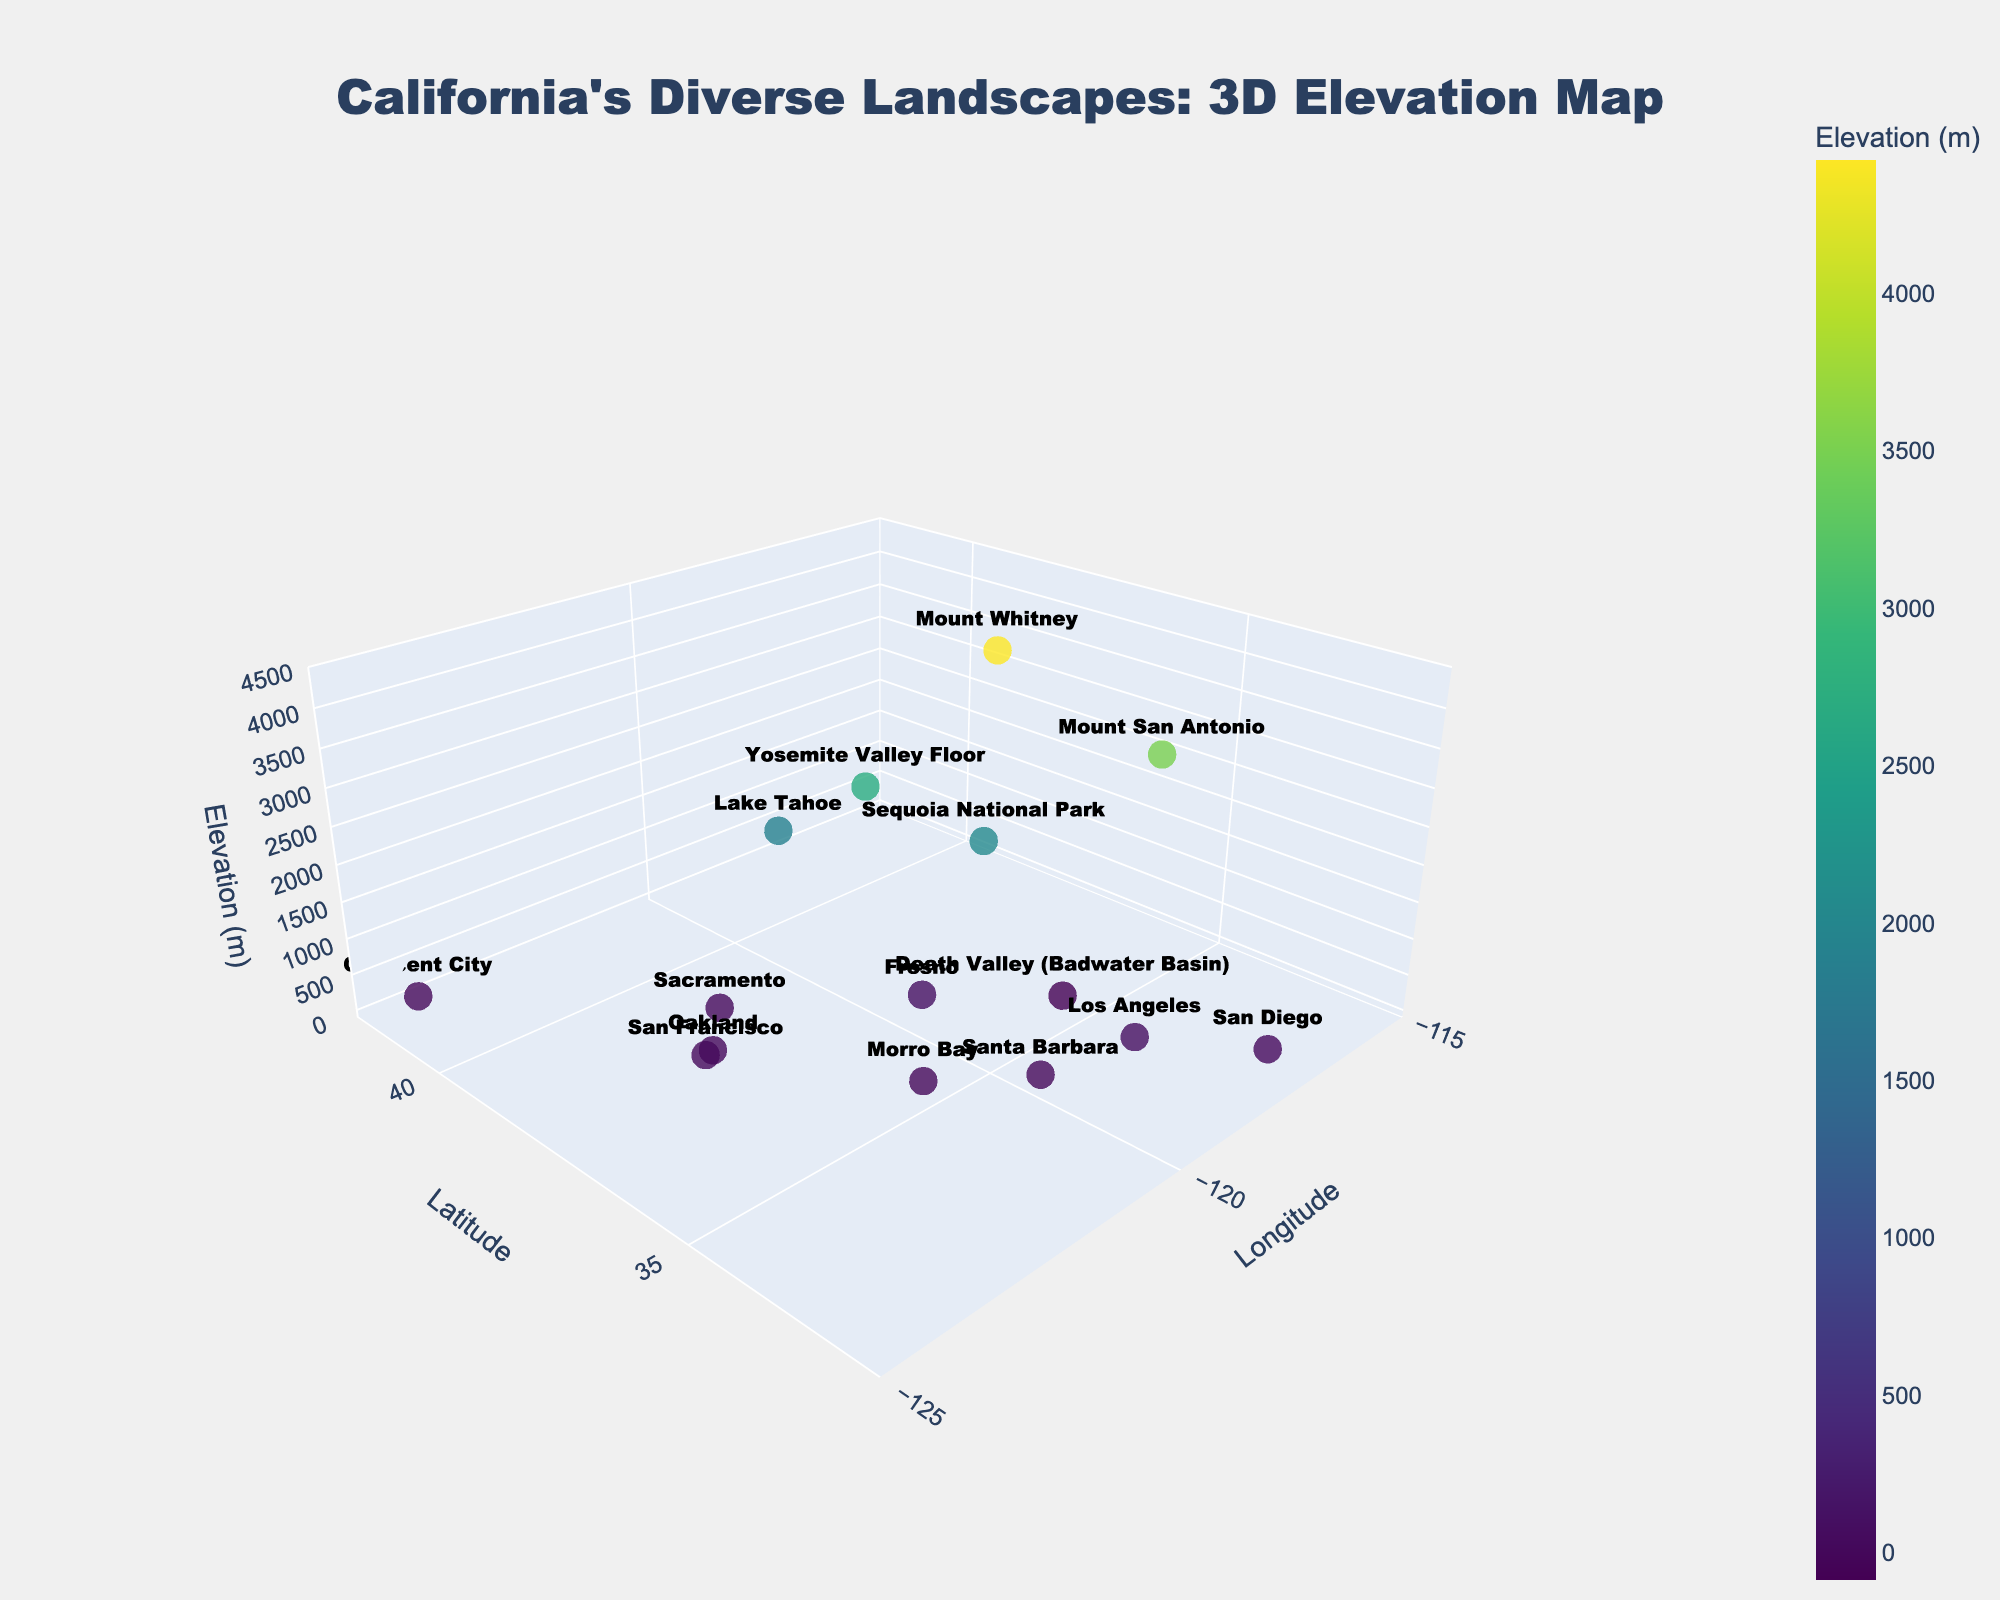What is the title of the figure? The title of the figure is displayed prominently at the top and helps in identifying the subject of the visualization. Here, it reads "California's Diverse Landscapes: 3D Elevation Map." This provides an overarching summary of what the plot represents.
Answer: California's Diverse Landscapes: 3D Elevation Map What city in California has the lowest elevation in the figure? To find the city with the lowest elevation, locate the city with the minimum value on the elevation axis. Death Valley (Badwater Basin) is the only location with a negative elevation, indicating it is below sea level.
Answer: Death Valley (Badwater Basin) Which two locations have an elevation of zero meters? Scan the figure to identify the data points positioned at the zero elevation level. Morro Bay and Crescent City are located at sea level, as denoted by their elevation of zero meters.
Answer: Morro Bay and Crescent City How many data points are represented in the plot? Count the number of markers or data points in the plot. By examining the various locations plotted on the 3D map, there are 15 individual points.
Answer: 15 What is the difference in elevation between Mount Whitney and Yosemite Valley Floor? Identify the elevations of Mount Whitney and Yosemite Valley Floor from the plot. Mount Whitney's elevation is 4421 meters, and Yosemite Valley Floor's elevation is 2693 meters. Subtract the two values to obtain the difference: 4421 - 2693 = 1728 meters.
Answer: 1728 meters Which location has the highest elevation in the plot? Search for the data point that is positioned at the highest value on the elevation axis. Mount Whitney is the highest point in the figure with an elevation of 4421 meters.
Answer: Mount Whitney How does the elevation of Oakland compare to that of Sacramento? Compare the elevation values of Oakland and Sacramento on the elevation axis. Oakland has an elevation of 13 meters, whereas Sacramento has an elevation of 9 meters. Oakland's elevation is slightly higher than Sacramento's.
Answer: Oakland is higher What is the approximate elevation range depicted in the plot? To determine the elevation range, identify the highest and lowest elevation values. The highest is Mount Whitney at 4421 meters and the lowest is Death Valley (Badwater Basin) at -86 meters. The range is approximately 4421 - (-86) = 4507 meters.
Answer: Approximately 4507 meters Which coastal city has the lowest elevation? Identify the cities that are on the coast from the plot and check their elevations. San Francisco, Los Angeles, Santa Barbara, and San Diego are coastal cities; San Francisco has the lowest elevation among them at 16 meters.
Answer: San Francisco What is the average elevation of the three highest points in the plot? First, find the three highest points: Mount Whitney (4421 meters), Mount San Antonio (3506 meters), and Yosemite Valley Floor (2693 meters). Calculate the average by summing these elevations and dividing by three. (4421 + 3506 + 2693) / 3 = 10620 / 3 = 3540 meters.
Answer: 3540 meters 